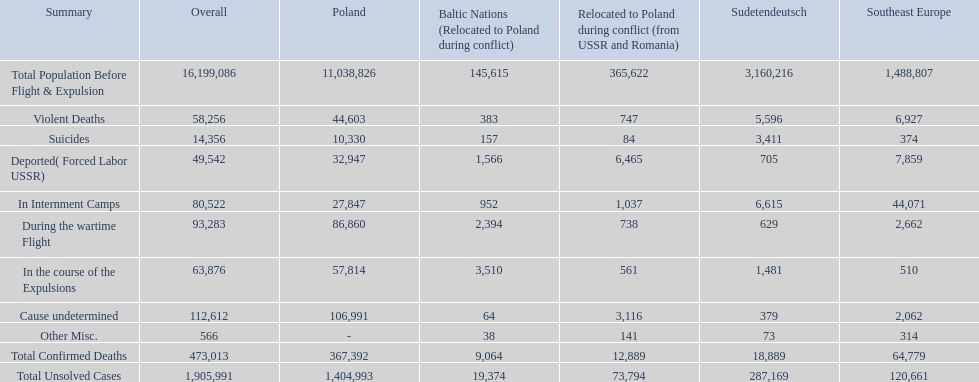What is the total of deaths in internment camps and during the wartime flight? 173,805. 